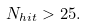Convert formula to latex. <formula><loc_0><loc_0><loc_500><loc_500>N _ { h i t } > 2 5 .</formula> 